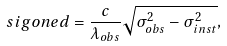Convert formula to latex. <formula><loc_0><loc_0><loc_500><loc_500>\ s i g o n e d = \frac { c } { \lambda _ { o b s } } \sqrt { \sigma _ { o b s } ^ { 2 } - \sigma _ { i n s t } ^ { 2 } } ,</formula> 